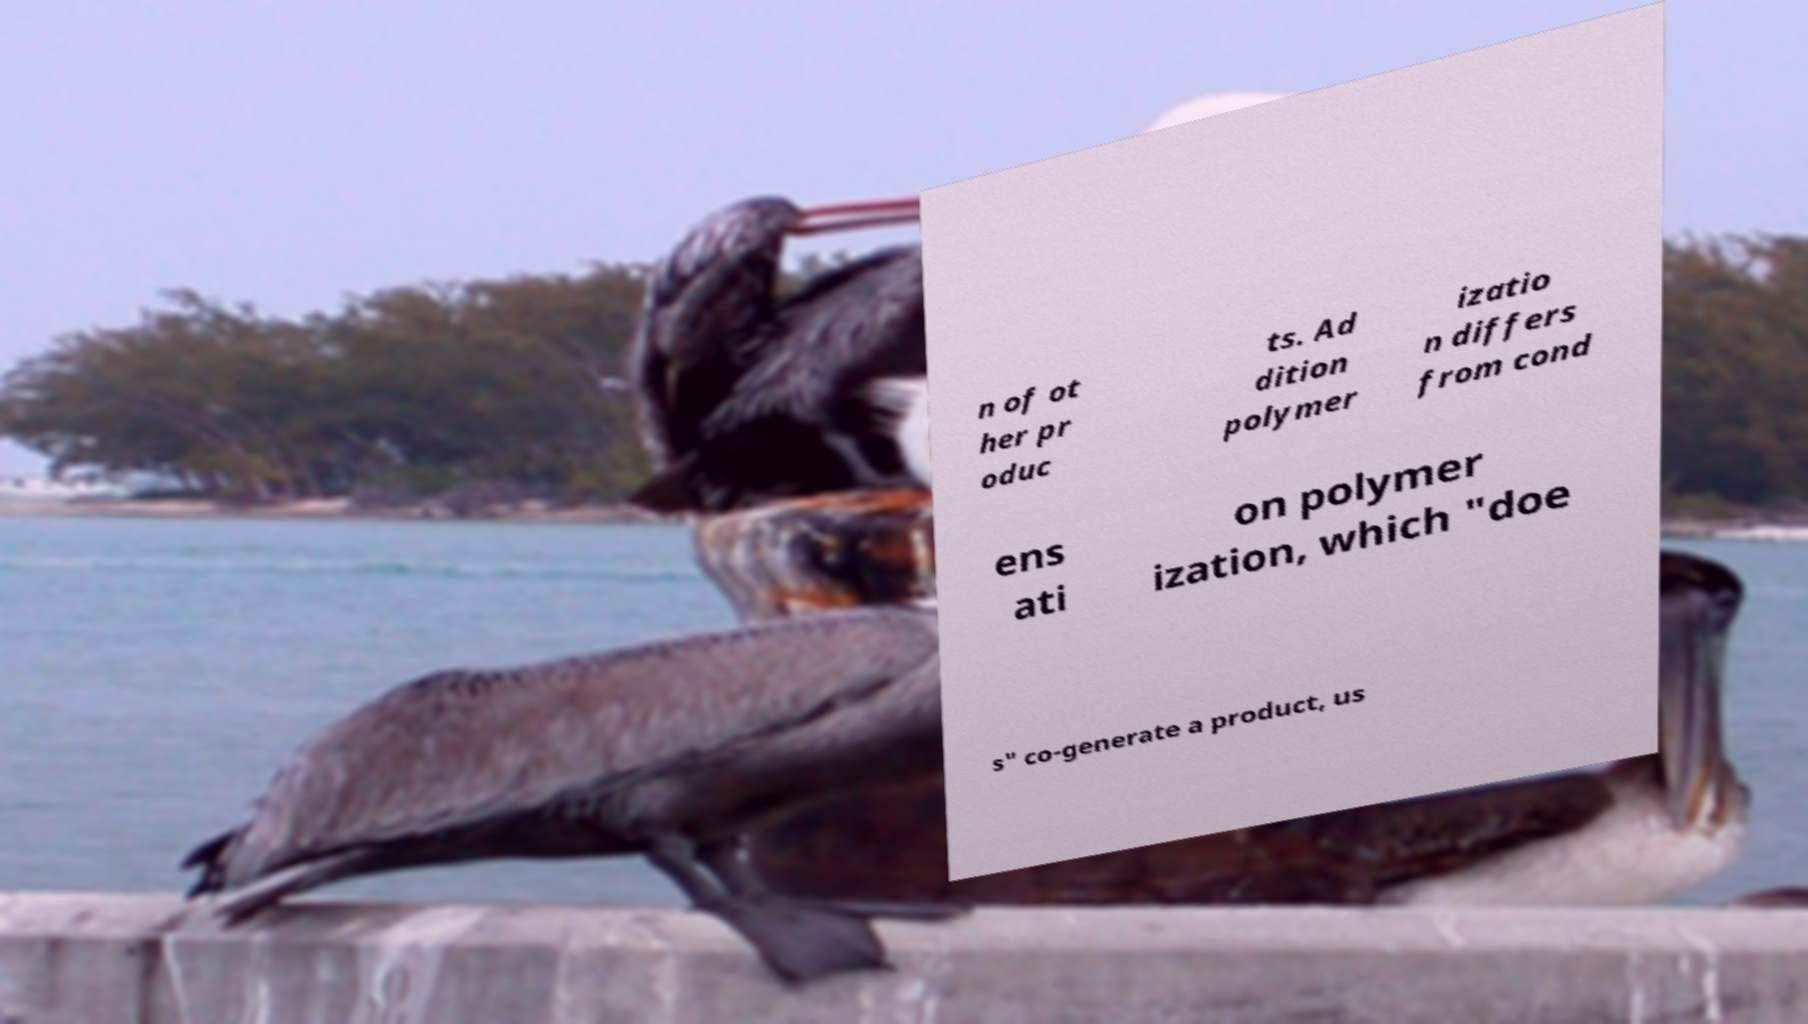What messages or text are displayed in this image? I need them in a readable, typed format. n of ot her pr oduc ts. Ad dition polymer izatio n differs from cond ens ati on polymer ization, which "doe s" co-generate a product, us 